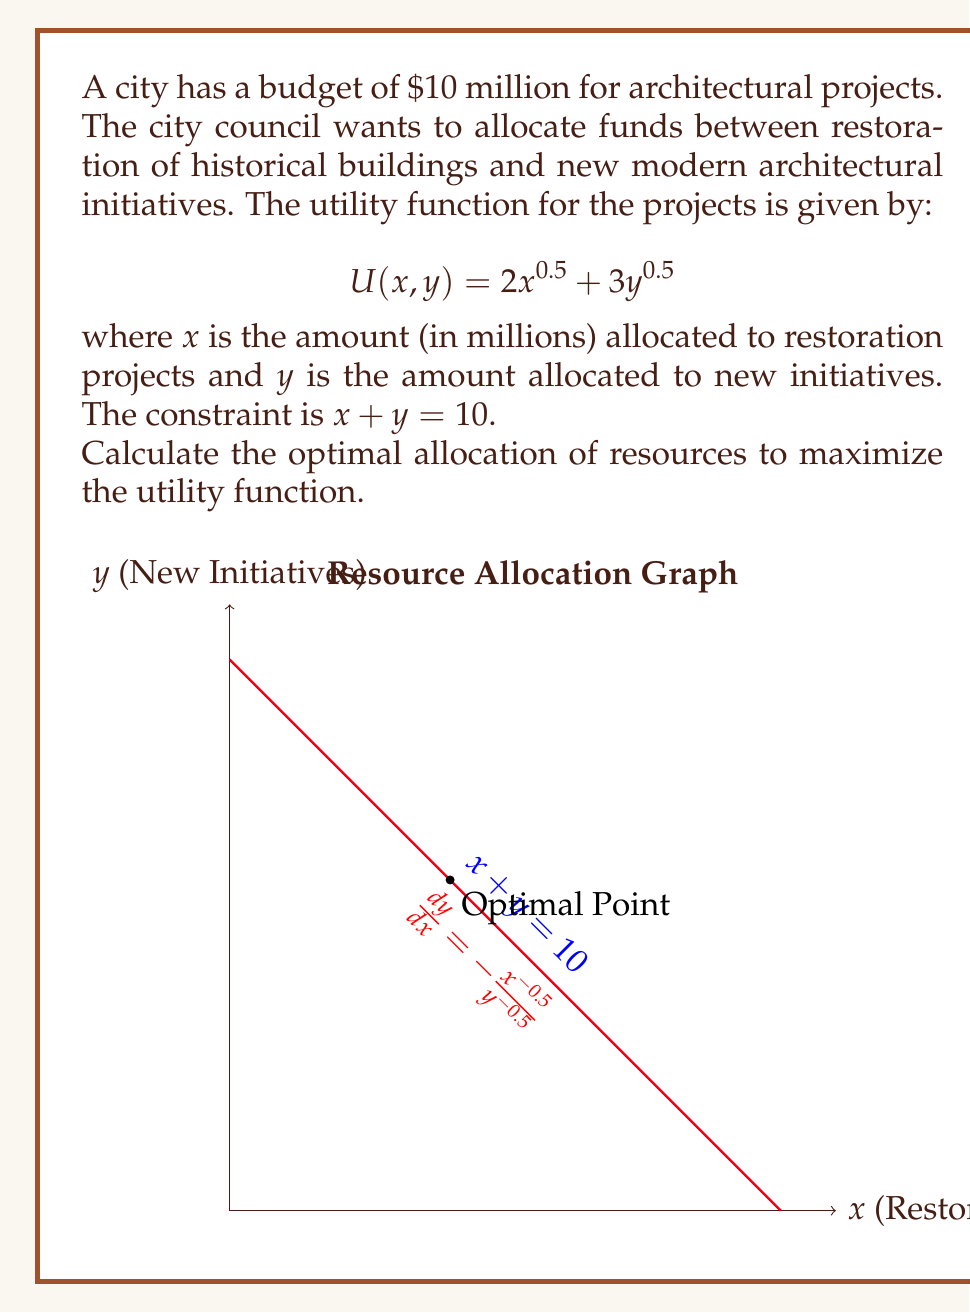Provide a solution to this math problem. To solve this problem, we'll use the method of Lagrange multipliers:

1) Set up the Lagrangian function:
   $$L(x, y, \lambda) = 2x^{0.5} + 3y^{0.5} + \lambda(10 - x - y)$$

2) Take partial derivatives and set them to zero:
   $$\frac{\partial L}{\partial x} = x^{-0.5} - \lambda = 0$$
   $$\frac{\partial L}{\partial y} = \frac{3}{2}y^{-0.5} - \lambda = 0$$
   $$\frac{\partial L}{\partial \lambda} = 10 - x - y = 0$$

3) From the first two equations:
   $$x^{-0.5} = \frac{3}{2}y^{-0.5}$$

4) Simplify:
   $$\frac{y^{0.5}}{x^{0.5}} = \frac{3}{2}$$
   $$\frac{y}{x} = \frac{9}{4}$$

5) Substitute into the constraint equation:
   $$x + \frac{9}{4}x = 10$$
   $$\frac{13}{4}x = 10$$
   $$x = \frac{40}{13} \approx 3.08$$

6) Calculate y:
   $$y = 10 - x = 10 - \frac{40}{13} = \frac{90}{13} \approx 6.92$$

7) Verify that this is a maximum by checking the second derivatives (omitted for brevity).

The graph shows the constraint line and the tangent line of the utility function at the optimal point.
Answer: Restoration: $\frac{40}{13}$ million, New Initiatives: $\frac{90}{13}$ million 